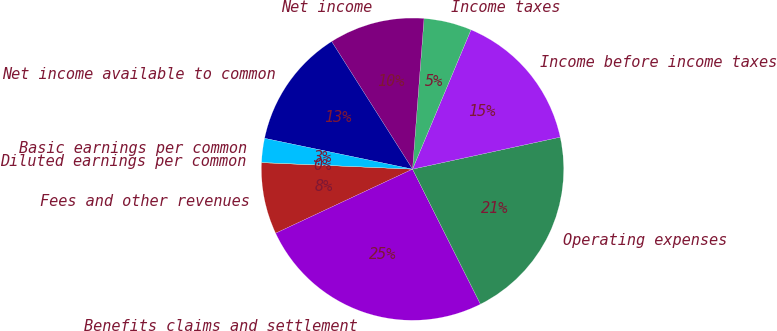<chart> <loc_0><loc_0><loc_500><loc_500><pie_chart><fcel>Fees and other revenues<fcel>Benefits claims and settlement<fcel>Operating expenses<fcel>Income before income taxes<fcel>Income taxes<fcel>Net income<fcel>Net income available to common<fcel>Basic earnings per common<fcel>Diluted earnings per common<nl><fcel>7.65%<fcel>25.45%<fcel>20.98%<fcel>15.28%<fcel>5.11%<fcel>10.2%<fcel>12.74%<fcel>2.57%<fcel>0.02%<nl></chart> 